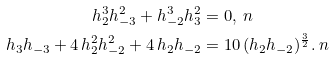Convert formula to latex. <formula><loc_0><loc_0><loc_500><loc_500>h _ { 2 } ^ { 3 } h _ { - 3 } ^ { 2 } + h _ { - 2 } ^ { 3 } h _ { 3 } ^ { 2 } & = 0 , \ n \\ h _ { 3 } h _ { - 3 } + 4 \, h _ { 2 } ^ { 2 } h _ { - 2 } ^ { 2 } + 4 \, h _ { 2 } h _ { - 2 } & = 1 0 \, ( h _ { 2 } h _ { - 2 } ) ^ { \frac { 3 } { 2 } } . \ n</formula> 